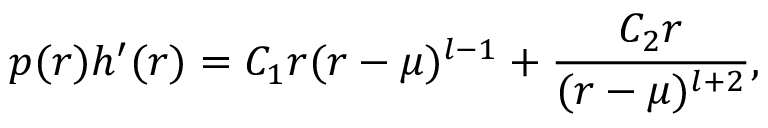Convert formula to latex. <formula><loc_0><loc_0><loc_500><loc_500>p ( r ) h ^ { \prime } ( r ) = C _ { 1 } r ( r - \mu ) ^ { l - 1 } + { \frac { C _ { 2 } r } { ( r - \mu ) ^ { l + 2 } } } ,</formula> 